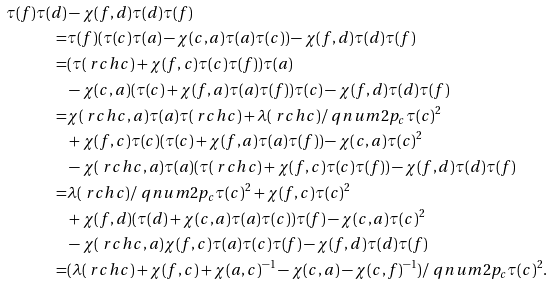Convert formula to latex. <formula><loc_0><loc_0><loc_500><loc_500>\tau ( f ) \tau ( d ) & - \chi ( f , d ) \tau ( d ) \tau ( f ) \\ = & \tau ( f ) ( \tau ( c ) \tau ( a ) - \chi ( c , a ) \tau ( a ) \tau ( c ) ) - \chi ( f , d ) \tau ( d ) \tau ( f ) \\ = & ( \tau ( \ r c h { c } ) + \chi ( f , c ) \tau ( c ) \tau ( f ) ) \tau ( a ) \\ & - \chi ( c , a ) ( \tau ( c ) + \chi ( f , a ) \tau ( a ) \tau ( f ) ) \tau ( c ) - \chi ( f , d ) \tau ( d ) \tau ( f ) \\ = & \chi ( \ r c h { c } , a ) \tau ( a ) \tau ( \ r c h { c } ) + \lambda ( \ r c h { c } ) / \ q n u m { 2 } { p _ { c } } \tau ( c ) ^ { 2 } \\ & + \chi ( f , c ) \tau ( c ) ( \tau ( c ) + \chi ( f , a ) \tau ( a ) \tau ( f ) ) - \chi ( c , a ) \tau ( c ) ^ { 2 } \\ & - \chi ( \ r c h { c } , a ) \tau ( a ) ( \tau ( \ r c h { c } ) + \chi ( f , c ) \tau ( c ) \tau ( f ) ) - \chi ( f , d ) \tau ( d ) \tau ( f ) \\ = & \lambda ( \ r c h { c } ) / \ q n u m { 2 } { p _ { c } } \tau ( c ) ^ { 2 } + \chi ( f , c ) \tau ( c ) ^ { 2 } \\ & + \chi ( f , d ) ( \tau ( d ) + \chi ( c , a ) \tau ( a ) \tau ( c ) ) \tau ( f ) - \chi ( c , a ) \tau ( c ) ^ { 2 } \\ & - \chi ( \ r c h { c } , a ) \chi ( f , c ) \tau ( a ) \tau ( c ) \tau ( f ) - \chi ( f , d ) \tau ( d ) \tau ( f ) \\ = & ( \lambda ( \ r c h { c } ) + \chi ( f , c ) + \chi ( a , c ) ^ { - 1 } - \chi ( c , a ) - \chi ( c , f ) ^ { - 1 } ) / \ q n u m { 2 } { p _ { c } } \tau ( c ) ^ { 2 } .</formula> 